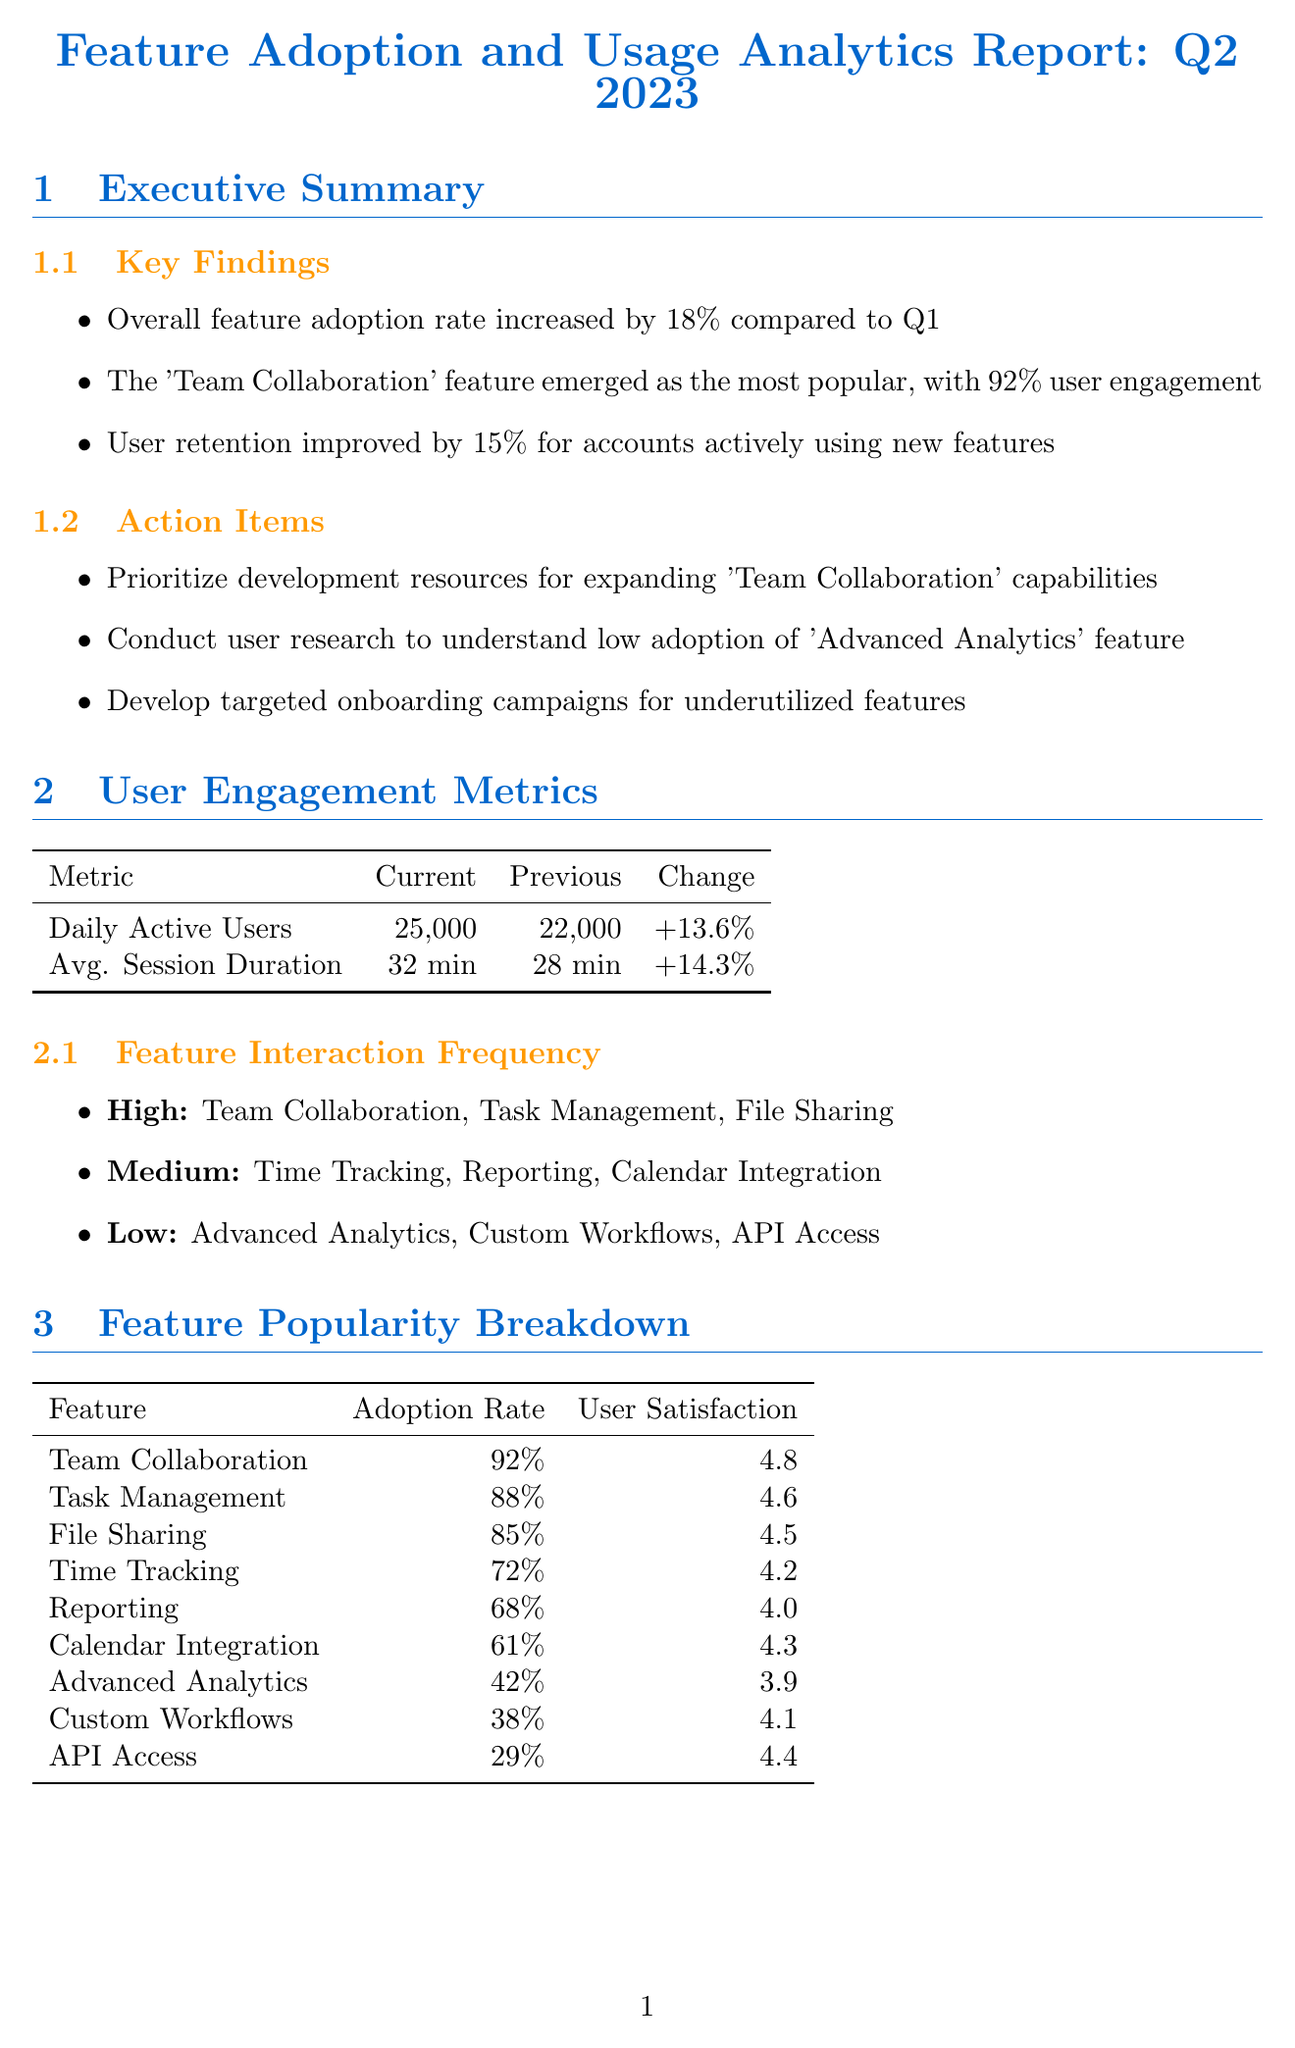What is the overall feature adoption rate increase compared to Q1? The overall feature adoption rate increased by 18% when compared to Q1.
Answer: 18% Which feature has the highest user engagement? The 'Team Collaboration' feature emerged as the most popular, with a user engagement of 92%.
Answer: 'Team Collaboration' What is the current net promoter score? The current net promoter score is shown as 68 in the report.
Answer: 68 What percentage improvement was noted in user retention? The report highlights a 15% improvement in user retention for accounts using new features.
Answer: 15% What are the top contributing features to the increase in customer lifetime value? The features that contributed the most to customer lifetime value increase are Team Collaboration, Task Management, and Reporting.
Answer: Team Collaboration, Task Management, Reporting What was the reduction in customer support tickets? The report states that there was an 18% reduction in customer support tickets.
Answer: 18% What is a high-priority recommendation mentioned in the report? The report recommends enhancing the Team Collaboration feature with real-time editing and commenting as a high priority.
Answer: Enhance Team Collaboration feature How many daily active users are reported currently? The current number of daily active users is 25,000 according to the document.
Answer: 25,000 What feature had the lowest adoption rate? The 'API Access' feature had the lowest adoption rate at 29%.
Answer: 'API Access' 